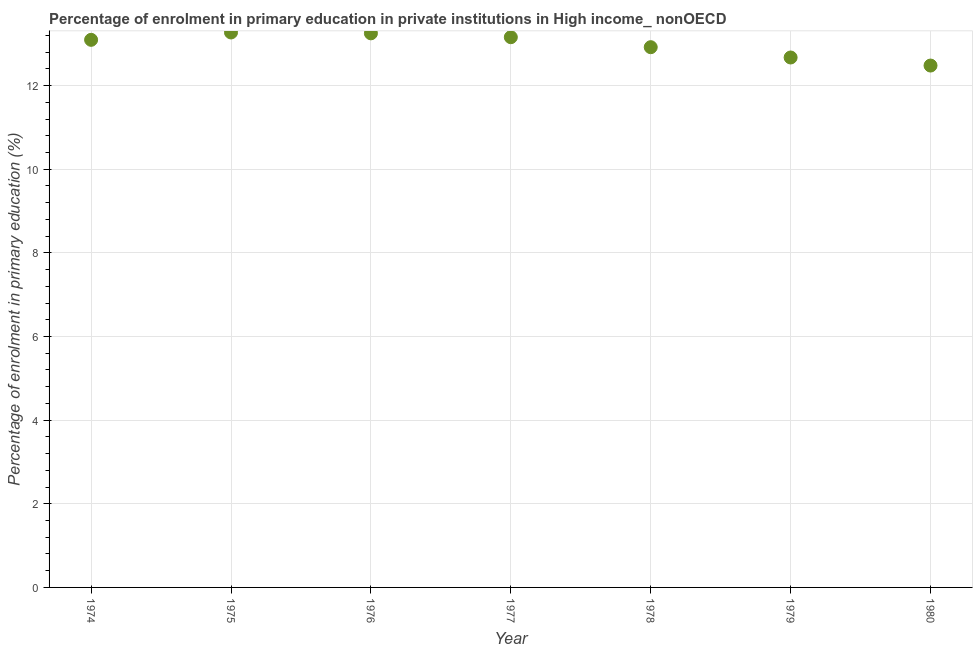What is the enrolment percentage in primary education in 1978?
Your answer should be compact. 12.92. Across all years, what is the maximum enrolment percentage in primary education?
Make the answer very short. 13.27. Across all years, what is the minimum enrolment percentage in primary education?
Offer a terse response. 12.48. In which year was the enrolment percentage in primary education maximum?
Your response must be concise. 1975. What is the sum of the enrolment percentage in primary education?
Offer a very short reply. 90.85. What is the difference between the enrolment percentage in primary education in 1975 and 1977?
Offer a terse response. 0.11. What is the average enrolment percentage in primary education per year?
Provide a succinct answer. 12.98. What is the median enrolment percentage in primary education?
Offer a very short reply. 13.1. In how many years, is the enrolment percentage in primary education greater than 8 %?
Your answer should be compact. 7. Do a majority of the years between 1976 and 1980 (inclusive) have enrolment percentage in primary education greater than 10 %?
Your response must be concise. Yes. What is the ratio of the enrolment percentage in primary education in 1974 to that in 1977?
Provide a succinct answer. 1. What is the difference between the highest and the second highest enrolment percentage in primary education?
Your answer should be compact. 0.02. What is the difference between the highest and the lowest enrolment percentage in primary education?
Offer a very short reply. 0.79. How many dotlines are there?
Make the answer very short. 1. How many years are there in the graph?
Give a very brief answer. 7. What is the difference between two consecutive major ticks on the Y-axis?
Your answer should be compact. 2. Does the graph contain grids?
Your answer should be compact. Yes. What is the title of the graph?
Provide a succinct answer. Percentage of enrolment in primary education in private institutions in High income_ nonOECD. What is the label or title of the X-axis?
Keep it short and to the point. Year. What is the label or title of the Y-axis?
Give a very brief answer. Percentage of enrolment in primary education (%). What is the Percentage of enrolment in primary education (%) in 1974?
Offer a very short reply. 13.1. What is the Percentage of enrolment in primary education (%) in 1975?
Your answer should be compact. 13.27. What is the Percentage of enrolment in primary education (%) in 1976?
Ensure brevity in your answer.  13.25. What is the Percentage of enrolment in primary education (%) in 1977?
Ensure brevity in your answer.  13.16. What is the Percentage of enrolment in primary education (%) in 1978?
Provide a succinct answer. 12.92. What is the Percentage of enrolment in primary education (%) in 1979?
Give a very brief answer. 12.67. What is the Percentage of enrolment in primary education (%) in 1980?
Make the answer very short. 12.48. What is the difference between the Percentage of enrolment in primary education (%) in 1974 and 1975?
Your answer should be compact. -0.18. What is the difference between the Percentage of enrolment in primary education (%) in 1974 and 1976?
Offer a terse response. -0.16. What is the difference between the Percentage of enrolment in primary education (%) in 1974 and 1977?
Your answer should be very brief. -0.06. What is the difference between the Percentage of enrolment in primary education (%) in 1974 and 1978?
Ensure brevity in your answer.  0.18. What is the difference between the Percentage of enrolment in primary education (%) in 1974 and 1979?
Give a very brief answer. 0.42. What is the difference between the Percentage of enrolment in primary education (%) in 1974 and 1980?
Your response must be concise. 0.62. What is the difference between the Percentage of enrolment in primary education (%) in 1975 and 1976?
Offer a very short reply. 0.02. What is the difference between the Percentage of enrolment in primary education (%) in 1975 and 1977?
Your response must be concise. 0.11. What is the difference between the Percentage of enrolment in primary education (%) in 1975 and 1978?
Give a very brief answer. 0.35. What is the difference between the Percentage of enrolment in primary education (%) in 1975 and 1979?
Offer a terse response. 0.6. What is the difference between the Percentage of enrolment in primary education (%) in 1975 and 1980?
Your answer should be very brief. 0.79. What is the difference between the Percentage of enrolment in primary education (%) in 1976 and 1977?
Keep it short and to the point. 0.09. What is the difference between the Percentage of enrolment in primary education (%) in 1976 and 1978?
Provide a succinct answer. 0.33. What is the difference between the Percentage of enrolment in primary education (%) in 1976 and 1979?
Your answer should be compact. 0.58. What is the difference between the Percentage of enrolment in primary education (%) in 1976 and 1980?
Make the answer very short. 0.77. What is the difference between the Percentage of enrolment in primary education (%) in 1977 and 1978?
Offer a terse response. 0.24. What is the difference between the Percentage of enrolment in primary education (%) in 1977 and 1979?
Your answer should be compact. 0.49. What is the difference between the Percentage of enrolment in primary education (%) in 1977 and 1980?
Give a very brief answer. 0.68. What is the difference between the Percentage of enrolment in primary education (%) in 1978 and 1979?
Provide a short and direct response. 0.25. What is the difference between the Percentage of enrolment in primary education (%) in 1978 and 1980?
Provide a succinct answer. 0.44. What is the difference between the Percentage of enrolment in primary education (%) in 1979 and 1980?
Keep it short and to the point. 0.19. What is the ratio of the Percentage of enrolment in primary education (%) in 1974 to that in 1975?
Your response must be concise. 0.99. What is the ratio of the Percentage of enrolment in primary education (%) in 1974 to that in 1977?
Offer a very short reply. 0.99. What is the ratio of the Percentage of enrolment in primary education (%) in 1974 to that in 1978?
Provide a short and direct response. 1.01. What is the ratio of the Percentage of enrolment in primary education (%) in 1974 to that in 1979?
Offer a terse response. 1.03. What is the ratio of the Percentage of enrolment in primary education (%) in 1974 to that in 1980?
Provide a short and direct response. 1.05. What is the ratio of the Percentage of enrolment in primary education (%) in 1975 to that in 1978?
Offer a very short reply. 1.03. What is the ratio of the Percentage of enrolment in primary education (%) in 1975 to that in 1979?
Offer a terse response. 1.05. What is the ratio of the Percentage of enrolment in primary education (%) in 1975 to that in 1980?
Provide a short and direct response. 1.06. What is the ratio of the Percentage of enrolment in primary education (%) in 1976 to that in 1978?
Ensure brevity in your answer.  1.03. What is the ratio of the Percentage of enrolment in primary education (%) in 1976 to that in 1979?
Ensure brevity in your answer.  1.05. What is the ratio of the Percentage of enrolment in primary education (%) in 1976 to that in 1980?
Give a very brief answer. 1.06. What is the ratio of the Percentage of enrolment in primary education (%) in 1977 to that in 1979?
Make the answer very short. 1.04. What is the ratio of the Percentage of enrolment in primary education (%) in 1977 to that in 1980?
Give a very brief answer. 1.05. What is the ratio of the Percentage of enrolment in primary education (%) in 1978 to that in 1980?
Your answer should be compact. 1.03. What is the ratio of the Percentage of enrolment in primary education (%) in 1979 to that in 1980?
Ensure brevity in your answer.  1.01. 